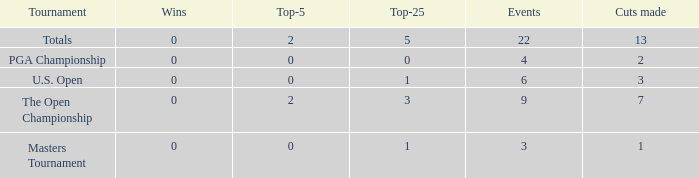What is the fewest number of top-25s for events with more than 13 cuts made? None. 